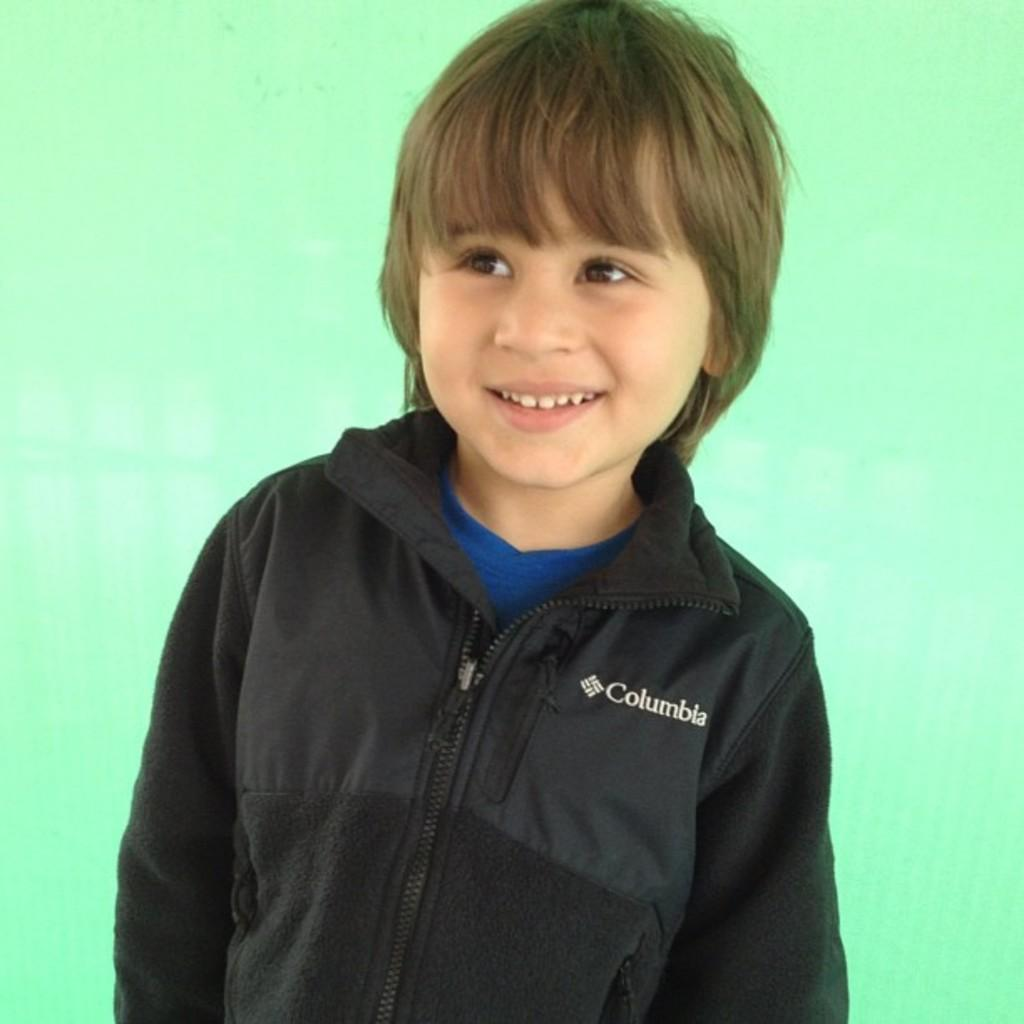Who is present in the image? There is a boy in the image. What is the boy's expression in the image? The boy is smiling in the image. What color is the background of the image? The background of the image is green. What type of frame is around the boy in the image? There is no frame visible around the boy in the image. What kind of truck can be seen in the background of the image? There is no truck present in the image; the background is green. 